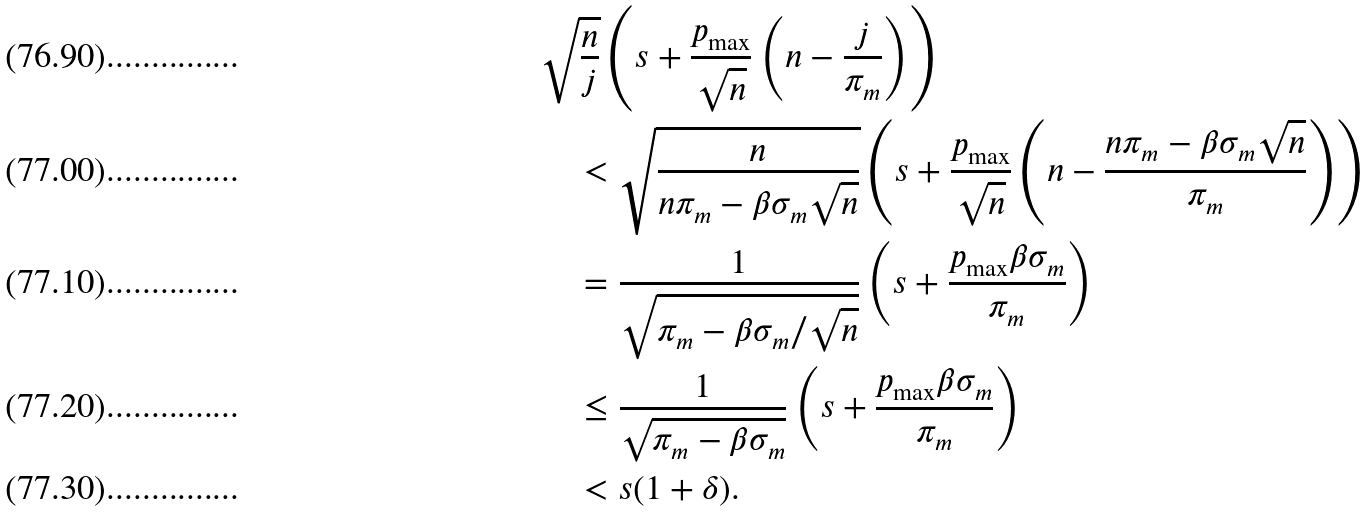Convert formula to latex. <formula><loc_0><loc_0><loc_500><loc_500>& \sqrt { \frac { n } { j } } \left ( s + \frac { p _ { \max } } { \sqrt { n } } \left ( n - \frac { j } { \pi _ { m } } \right ) \right ) \\ & \quad < \sqrt { \frac { n } { n \pi _ { m } - \beta \sigma _ { m } \sqrt { n } } } \left ( s + \frac { p _ { \max } } { \sqrt { n } } \left ( n - \frac { n \pi _ { m } - \beta \sigma _ { m } \sqrt { n } } { \pi _ { m } } \right ) \right ) \\ & \quad = \frac { 1 } { \sqrt { \pi _ { m } - \beta \sigma _ { m } / \sqrt { n } } } \left ( s + \frac { p _ { \max } \beta \sigma _ { m } } { \pi _ { m } } \right ) \\ & \quad \leq \frac { 1 } { \sqrt { \pi _ { m } - \beta \sigma _ { m } } } \left ( s + \frac { p _ { \max } \beta \sigma _ { m } } { \pi _ { m } } \right ) \\ & \quad < s ( 1 + \delta ) .</formula> 